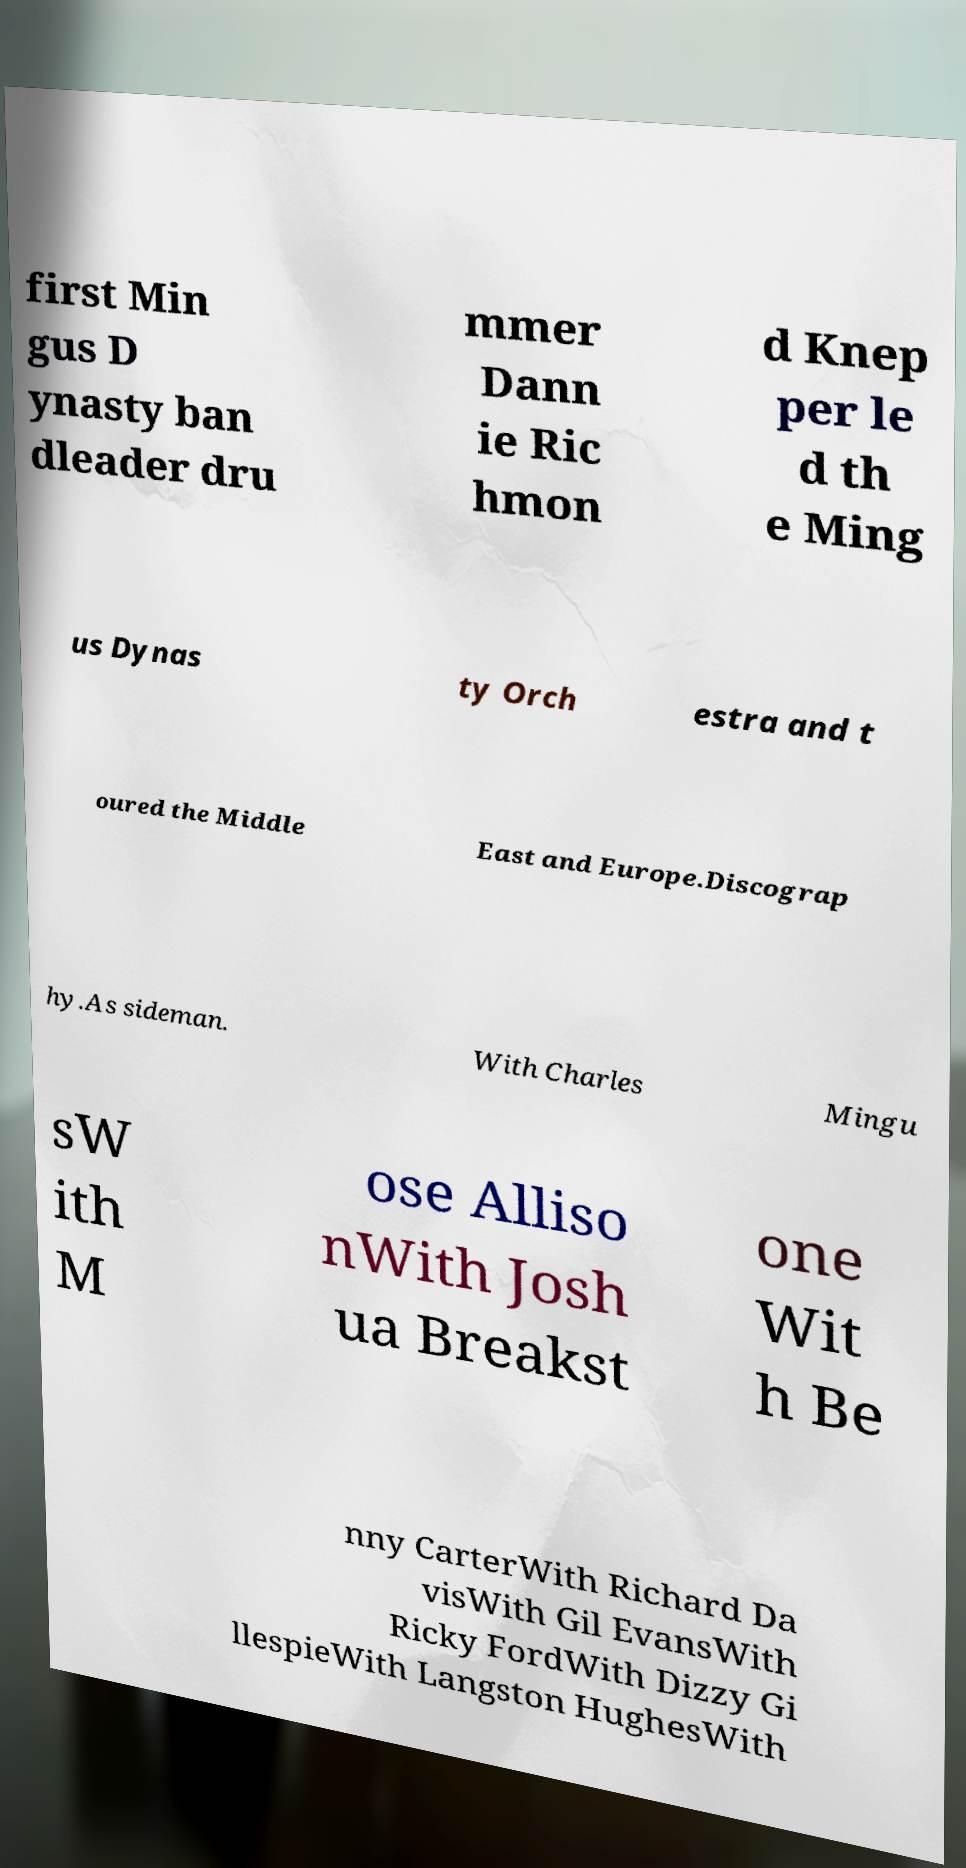Could you assist in decoding the text presented in this image and type it out clearly? first Min gus D ynasty ban dleader dru mmer Dann ie Ric hmon d Knep per le d th e Ming us Dynas ty Orch estra and t oured the Middle East and Europe.Discograp hy.As sideman. With Charles Mingu sW ith M ose Alliso nWith Josh ua Breakst one Wit h Be nny CarterWith Richard Da visWith Gil EvansWith Ricky FordWith Dizzy Gi llespieWith Langston HughesWith 